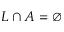<formula> <loc_0><loc_0><loc_500><loc_500>L \cap A = \emptyset</formula> 